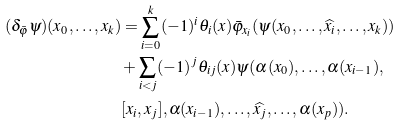<formula> <loc_0><loc_0><loc_500><loc_500>( \delta _ { \bar { \varphi } } \psi ) ( x _ { 0 } , \dots , x _ { k } ) & = \sum _ { i = 0 } ^ { k } ( - 1 ) ^ { i } \theta _ { i } ( x ) \bar { \varphi } _ { x _ { i } } ( \psi ( x _ { 0 } , \dots , \widehat { x _ { i } } , \dots , x _ { k } ) ) \\ & + \sum _ { i < j } ( - 1 ) ^ { j } \theta _ { i j } ( x ) \psi ( \alpha ( x _ { 0 } ) , \dots , \alpha ( x _ { i - 1 } ) , \\ & [ x _ { i } , x _ { j } ] , \alpha ( x _ { i - 1 } ) , \dots , \widehat { x _ { j } } , \dots , \alpha ( x _ { p } ) ) .</formula> 